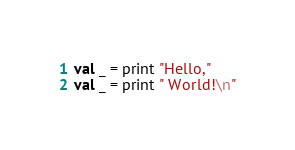Convert code to text. <code><loc_0><loc_0><loc_500><loc_500><_SML_>val _ = print "Hello,"
val _ = print " World!\n"

</code> 